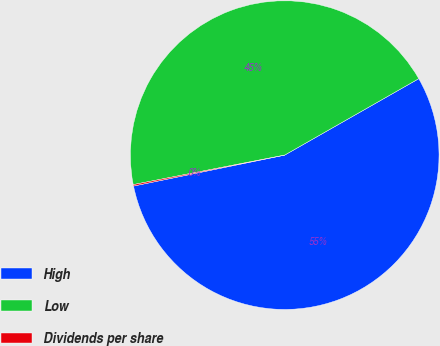<chart> <loc_0><loc_0><loc_500><loc_500><pie_chart><fcel>High<fcel>Low<fcel>Dividends per share<nl><fcel>55.03%<fcel>44.82%<fcel>0.15%<nl></chart> 